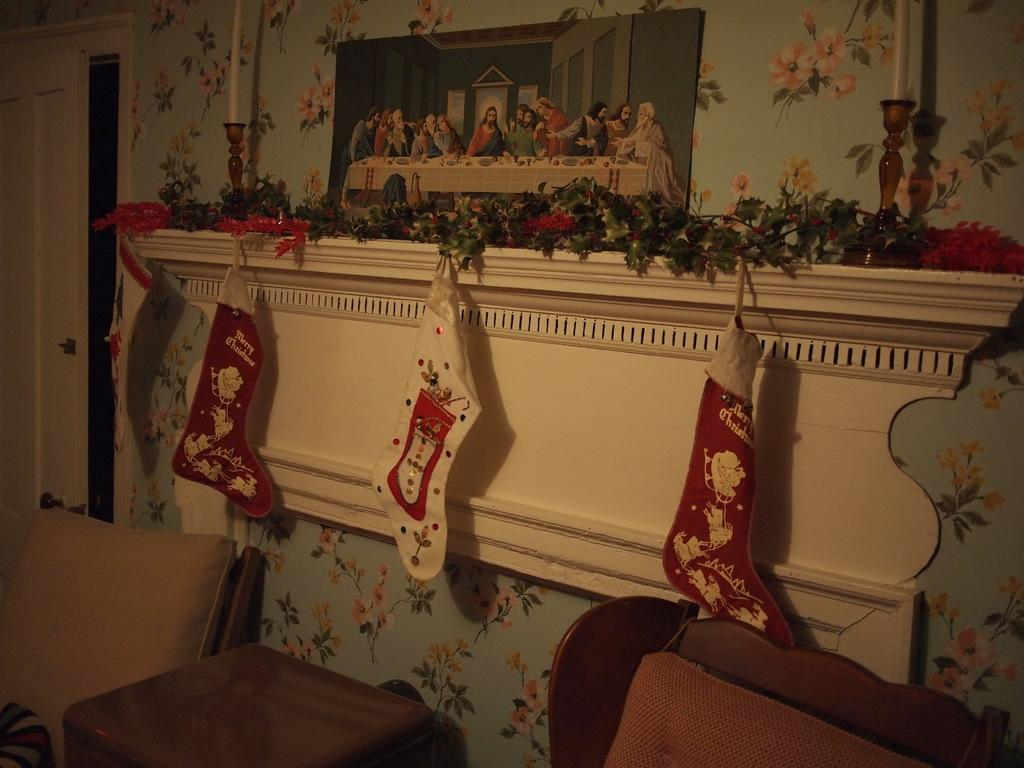What is one of the main features of the image? There is a door in the image. What can be seen hanging on the wall in the image? There is a wall hanging in the image. What items are used for lighting in the image? There are candles and candle holders in the image. What type of decorative elements are present in the image? There are decorations in the image. What piece of furniture is visible in the image? There is a side table in the image. What type of seating is available in the image? There are chairs in the image. Where can the toothpaste be found in the image? There is no toothpaste present in the image. What type of frame is used for the wall hanging in the image? The provided facts do not mention a frame for the wall hanging, so we cannot determine its type from the image. 